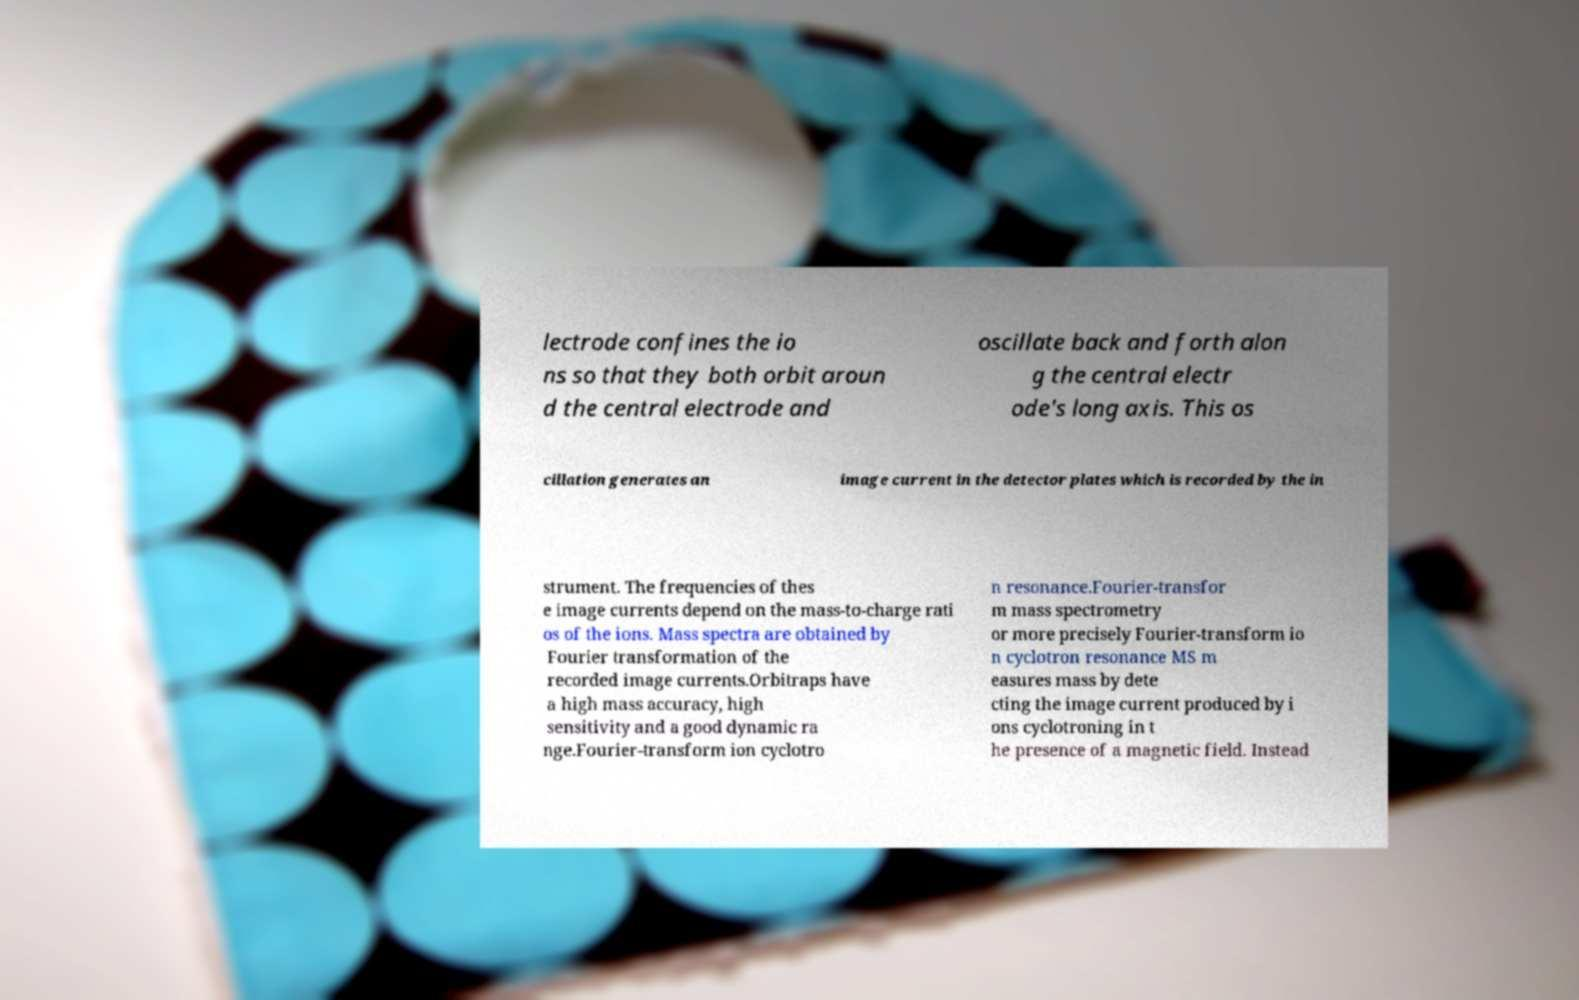Can you read and provide the text displayed in the image?This photo seems to have some interesting text. Can you extract and type it out for me? lectrode confines the io ns so that they both orbit aroun d the central electrode and oscillate back and forth alon g the central electr ode's long axis. This os cillation generates an image current in the detector plates which is recorded by the in strument. The frequencies of thes e image currents depend on the mass-to-charge rati os of the ions. Mass spectra are obtained by Fourier transformation of the recorded image currents.Orbitraps have a high mass accuracy, high sensitivity and a good dynamic ra nge.Fourier-transform ion cyclotro n resonance.Fourier-transfor m mass spectrometry or more precisely Fourier-transform io n cyclotron resonance MS m easures mass by dete cting the image current produced by i ons cyclotroning in t he presence of a magnetic field. Instead 